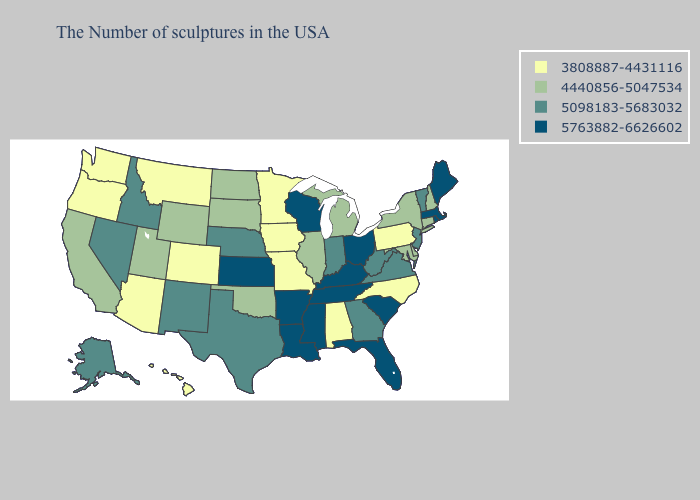What is the value of Oregon?
Give a very brief answer. 3808887-4431116. Does Iowa have a lower value than Alabama?
Write a very short answer. No. Among the states that border Oklahoma , which have the lowest value?
Give a very brief answer. Missouri, Colorado. Among the states that border Illinois , does Missouri have the lowest value?
Concise answer only. Yes. What is the highest value in the MidWest ?
Quick response, please. 5763882-6626602. Name the states that have a value in the range 3808887-4431116?
Be succinct. Pennsylvania, North Carolina, Alabama, Missouri, Minnesota, Iowa, Colorado, Montana, Arizona, Washington, Oregon, Hawaii. Does Kentucky have a lower value than Utah?
Keep it brief. No. Among the states that border Delaware , which have the highest value?
Be succinct. New Jersey. Which states have the lowest value in the USA?
Write a very short answer. Pennsylvania, North Carolina, Alabama, Missouri, Minnesota, Iowa, Colorado, Montana, Arizona, Washington, Oregon, Hawaii. Does the first symbol in the legend represent the smallest category?
Give a very brief answer. Yes. Name the states that have a value in the range 3808887-4431116?
Answer briefly. Pennsylvania, North Carolina, Alabama, Missouri, Minnesota, Iowa, Colorado, Montana, Arizona, Washington, Oregon, Hawaii. Among the states that border Florida , which have the highest value?
Quick response, please. Georgia. Name the states that have a value in the range 3808887-4431116?
Write a very short answer. Pennsylvania, North Carolina, Alabama, Missouri, Minnesota, Iowa, Colorado, Montana, Arizona, Washington, Oregon, Hawaii. Does Texas have the lowest value in the USA?
Keep it brief. No. Does Nevada have a higher value than New Hampshire?
Be succinct. Yes. 